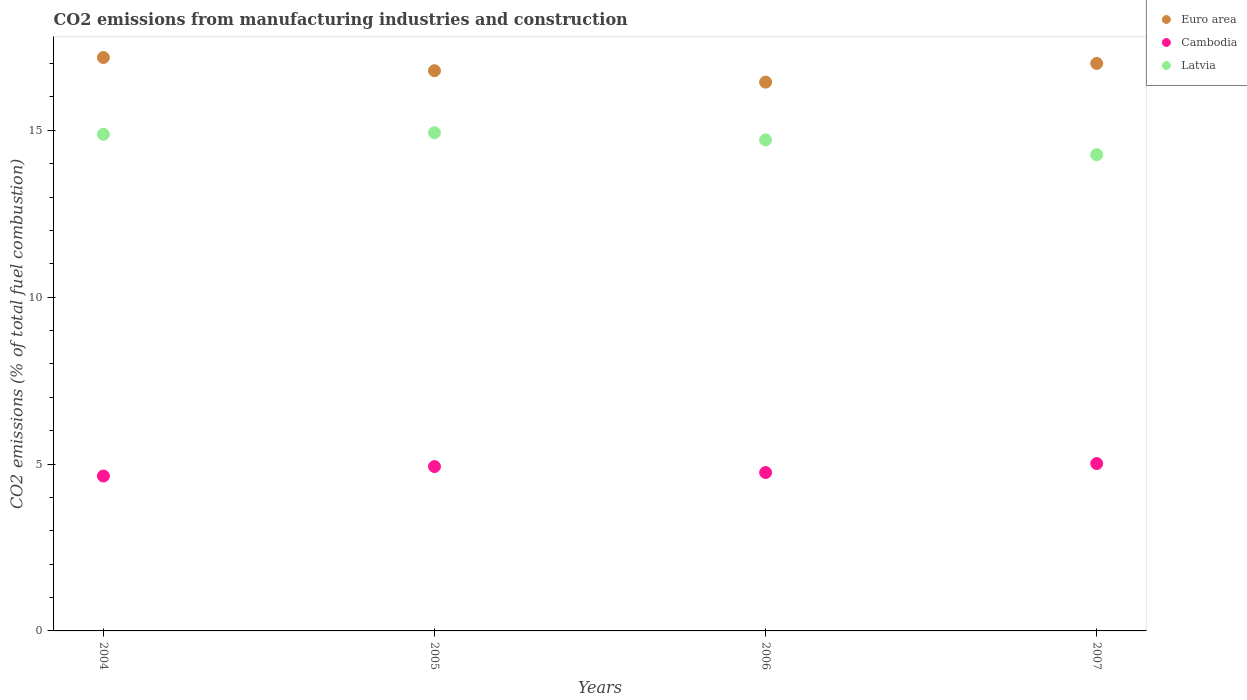Is the number of dotlines equal to the number of legend labels?
Provide a succinct answer. Yes. What is the amount of CO2 emitted in Euro area in 2007?
Your response must be concise. 17. Across all years, what is the maximum amount of CO2 emitted in Cambodia?
Offer a very short reply. 5.01. Across all years, what is the minimum amount of CO2 emitted in Cambodia?
Offer a terse response. 4.64. In which year was the amount of CO2 emitted in Cambodia minimum?
Offer a terse response. 2004. What is the total amount of CO2 emitted in Latvia in the graph?
Provide a succinct answer. 58.79. What is the difference between the amount of CO2 emitted in Latvia in 2005 and that in 2007?
Keep it short and to the point. 0.66. What is the difference between the amount of CO2 emitted in Latvia in 2004 and the amount of CO2 emitted in Euro area in 2007?
Give a very brief answer. -2.12. What is the average amount of CO2 emitted in Cambodia per year?
Ensure brevity in your answer.  4.83. In the year 2005, what is the difference between the amount of CO2 emitted in Cambodia and amount of CO2 emitted in Latvia?
Provide a succinct answer. -10. What is the ratio of the amount of CO2 emitted in Cambodia in 2004 to that in 2006?
Make the answer very short. 0.98. What is the difference between the highest and the second highest amount of CO2 emitted in Cambodia?
Offer a terse response. 0.09. What is the difference between the highest and the lowest amount of CO2 emitted in Cambodia?
Ensure brevity in your answer.  0.37. Is the sum of the amount of CO2 emitted in Cambodia in 2005 and 2007 greater than the maximum amount of CO2 emitted in Latvia across all years?
Keep it short and to the point. No. Does the amount of CO2 emitted in Cambodia monotonically increase over the years?
Offer a very short reply. No. Is the amount of CO2 emitted in Cambodia strictly less than the amount of CO2 emitted in Latvia over the years?
Your response must be concise. Yes. What is the difference between two consecutive major ticks on the Y-axis?
Give a very brief answer. 5. Does the graph contain any zero values?
Your answer should be very brief. No. Where does the legend appear in the graph?
Your answer should be compact. Top right. How are the legend labels stacked?
Offer a very short reply. Vertical. What is the title of the graph?
Your answer should be very brief. CO2 emissions from manufacturing industries and construction. Does "Marshall Islands" appear as one of the legend labels in the graph?
Offer a very short reply. No. What is the label or title of the X-axis?
Offer a very short reply. Years. What is the label or title of the Y-axis?
Offer a very short reply. CO2 emissions (% of total fuel combustion). What is the CO2 emissions (% of total fuel combustion) of Euro area in 2004?
Make the answer very short. 17.18. What is the CO2 emissions (% of total fuel combustion) in Cambodia in 2004?
Provide a short and direct response. 4.64. What is the CO2 emissions (% of total fuel combustion) in Latvia in 2004?
Provide a short and direct response. 14.88. What is the CO2 emissions (% of total fuel combustion) of Euro area in 2005?
Your answer should be compact. 16.78. What is the CO2 emissions (% of total fuel combustion) of Cambodia in 2005?
Your answer should be very brief. 4.92. What is the CO2 emissions (% of total fuel combustion) in Latvia in 2005?
Ensure brevity in your answer.  14.93. What is the CO2 emissions (% of total fuel combustion) in Euro area in 2006?
Offer a very short reply. 16.44. What is the CO2 emissions (% of total fuel combustion) of Cambodia in 2006?
Make the answer very short. 4.75. What is the CO2 emissions (% of total fuel combustion) in Latvia in 2006?
Your answer should be compact. 14.71. What is the CO2 emissions (% of total fuel combustion) of Euro area in 2007?
Your answer should be compact. 17. What is the CO2 emissions (% of total fuel combustion) of Cambodia in 2007?
Keep it short and to the point. 5.01. What is the CO2 emissions (% of total fuel combustion) in Latvia in 2007?
Make the answer very short. 14.27. Across all years, what is the maximum CO2 emissions (% of total fuel combustion) in Euro area?
Provide a short and direct response. 17.18. Across all years, what is the maximum CO2 emissions (% of total fuel combustion) in Cambodia?
Your answer should be compact. 5.01. Across all years, what is the maximum CO2 emissions (% of total fuel combustion) in Latvia?
Provide a succinct answer. 14.93. Across all years, what is the minimum CO2 emissions (% of total fuel combustion) of Euro area?
Your response must be concise. 16.44. Across all years, what is the minimum CO2 emissions (% of total fuel combustion) in Cambodia?
Give a very brief answer. 4.64. Across all years, what is the minimum CO2 emissions (% of total fuel combustion) of Latvia?
Your answer should be compact. 14.27. What is the total CO2 emissions (% of total fuel combustion) in Euro area in the graph?
Provide a short and direct response. 67.41. What is the total CO2 emissions (% of total fuel combustion) in Cambodia in the graph?
Your response must be concise. 19.33. What is the total CO2 emissions (% of total fuel combustion) in Latvia in the graph?
Give a very brief answer. 58.79. What is the difference between the CO2 emissions (% of total fuel combustion) of Euro area in 2004 and that in 2005?
Give a very brief answer. 0.4. What is the difference between the CO2 emissions (% of total fuel combustion) of Cambodia in 2004 and that in 2005?
Give a very brief answer. -0.28. What is the difference between the CO2 emissions (% of total fuel combustion) in Latvia in 2004 and that in 2005?
Your answer should be compact. -0.05. What is the difference between the CO2 emissions (% of total fuel combustion) in Euro area in 2004 and that in 2006?
Your answer should be compact. 0.74. What is the difference between the CO2 emissions (% of total fuel combustion) of Cambodia in 2004 and that in 2006?
Ensure brevity in your answer.  -0.1. What is the difference between the CO2 emissions (% of total fuel combustion) in Latvia in 2004 and that in 2006?
Your response must be concise. 0.17. What is the difference between the CO2 emissions (% of total fuel combustion) of Euro area in 2004 and that in 2007?
Your answer should be compact. 0.18. What is the difference between the CO2 emissions (% of total fuel combustion) of Cambodia in 2004 and that in 2007?
Provide a succinct answer. -0.37. What is the difference between the CO2 emissions (% of total fuel combustion) in Latvia in 2004 and that in 2007?
Your answer should be compact. 0.61. What is the difference between the CO2 emissions (% of total fuel combustion) of Euro area in 2005 and that in 2006?
Provide a succinct answer. 0.34. What is the difference between the CO2 emissions (% of total fuel combustion) of Cambodia in 2005 and that in 2006?
Your answer should be compact. 0.18. What is the difference between the CO2 emissions (% of total fuel combustion) in Latvia in 2005 and that in 2006?
Provide a succinct answer. 0.21. What is the difference between the CO2 emissions (% of total fuel combustion) in Euro area in 2005 and that in 2007?
Give a very brief answer. -0.22. What is the difference between the CO2 emissions (% of total fuel combustion) in Cambodia in 2005 and that in 2007?
Provide a succinct answer. -0.09. What is the difference between the CO2 emissions (% of total fuel combustion) in Latvia in 2005 and that in 2007?
Give a very brief answer. 0.66. What is the difference between the CO2 emissions (% of total fuel combustion) of Euro area in 2006 and that in 2007?
Your answer should be very brief. -0.56. What is the difference between the CO2 emissions (% of total fuel combustion) in Cambodia in 2006 and that in 2007?
Offer a very short reply. -0.27. What is the difference between the CO2 emissions (% of total fuel combustion) in Latvia in 2006 and that in 2007?
Make the answer very short. 0.44. What is the difference between the CO2 emissions (% of total fuel combustion) of Euro area in 2004 and the CO2 emissions (% of total fuel combustion) of Cambodia in 2005?
Ensure brevity in your answer.  12.26. What is the difference between the CO2 emissions (% of total fuel combustion) in Euro area in 2004 and the CO2 emissions (% of total fuel combustion) in Latvia in 2005?
Provide a succinct answer. 2.25. What is the difference between the CO2 emissions (% of total fuel combustion) of Cambodia in 2004 and the CO2 emissions (% of total fuel combustion) of Latvia in 2005?
Keep it short and to the point. -10.29. What is the difference between the CO2 emissions (% of total fuel combustion) of Euro area in 2004 and the CO2 emissions (% of total fuel combustion) of Cambodia in 2006?
Give a very brief answer. 12.43. What is the difference between the CO2 emissions (% of total fuel combustion) in Euro area in 2004 and the CO2 emissions (% of total fuel combustion) in Latvia in 2006?
Your answer should be very brief. 2.47. What is the difference between the CO2 emissions (% of total fuel combustion) in Cambodia in 2004 and the CO2 emissions (% of total fuel combustion) in Latvia in 2006?
Provide a short and direct response. -10.07. What is the difference between the CO2 emissions (% of total fuel combustion) in Euro area in 2004 and the CO2 emissions (% of total fuel combustion) in Cambodia in 2007?
Provide a succinct answer. 12.17. What is the difference between the CO2 emissions (% of total fuel combustion) in Euro area in 2004 and the CO2 emissions (% of total fuel combustion) in Latvia in 2007?
Provide a succinct answer. 2.91. What is the difference between the CO2 emissions (% of total fuel combustion) of Cambodia in 2004 and the CO2 emissions (% of total fuel combustion) of Latvia in 2007?
Your response must be concise. -9.63. What is the difference between the CO2 emissions (% of total fuel combustion) in Euro area in 2005 and the CO2 emissions (% of total fuel combustion) in Cambodia in 2006?
Give a very brief answer. 12.04. What is the difference between the CO2 emissions (% of total fuel combustion) of Euro area in 2005 and the CO2 emissions (% of total fuel combustion) of Latvia in 2006?
Provide a succinct answer. 2.07. What is the difference between the CO2 emissions (% of total fuel combustion) of Cambodia in 2005 and the CO2 emissions (% of total fuel combustion) of Latvia in 2006?
Provide a short and direct response. -9.79. What is the difference between the CO2 emissions (% of total fuel combustion) of Euro area in 2005 and the CO2 emissions (% of total fuel combustion) of Cambodia in 2007?
Keep it short and to the point. 11.77. What is the difference between the CO2 emissions (% of total fuel combustion) of Euro area in 2005 and the CO2 emissions (% of total fuel combustion) of Latvia in 2007?
Provide a succinct answer. 2.52. What is the difference between the CO2 emissions (% of total fuel combustion) in Cambodia in 2005 and the CO2 emissions (% of total fuel combustion) in Latvia in 2007?
Your response must be concise. -9.34. What is the difference between the CO2 emissions (% of total fuel combustion) in Euro area in 2006 and the CO2 emissions (% of total fuel combustion) in Cambodia in 2007?
Offer a terse response. 11.43. What is the difference between the CO2 emissions (% of total fuel combustion) of Euro area in 2006 and the CO2 emissions (% of total fuel combustion) of Latvia in 2007?
Your answer should be compact. 2.17. What is the difference between the CO2 emissions (% of total fuel combustion) of Cambodia in 2006 and the CO2 emissions (% of total fuel combustion) of Latvia in 2007?
Your answer should be very brief. -9.52. What is the average CO2 emissions (% of total fuel combustion) of Euro area per year?
Give a very brief answer. 16.85. What is the average CO2 emissions (% of total fuel combustion) in Cambodia per year?
Give a very brief answer. 4.83. What is the average CO2 emissions (% of total fuel combustion) of Latvia per year?
Give a very brief answer. 14.7. In the year 2004, what is the difference between the CO2 emissions (% of total fuel combustion) in Euro area and CO2 emissions (% of total fuel combustion) in Cambodia?
Keep it short and to the point. 12.54. In the year 2004, what is the difference between the CO2 emissions (% of total fuel combustion) of Euro area and CO2 emissions (% of total fuel combustion) of Latvia?
Provide a succinct answer. 2.3. In the year 2004, what is the difference between the CO2 emissions (% of total fuel combustion) in Cambodia and CO2 emissions (% of total fuel combustion) in Latvia?
Offer a terse response. -10.24. In the year 2005, what is the difference between the CO2 emissions (% of total fuel combustion) in Euro area and CO2 emissions (% of total fuel combustion) in Cambodia?
Offer a terse response. 11.86. In the year 2005, what is the difference between the CO2 emissions (% of total fuel combustion) of Euro area and CO2 emissions (% of total fuel combustion) of Latvia?
Make the answer very short. 1.86. In the year 2005, what is the difference between the CO2 emissions (% of total fuel combustion) in Cambodia and CO2 emissions (% of total fuel combustion) in Latvia?
Ensure brevity in your answer.  -10. In the year 2006, what is the difference between the CO2 emissions (% of total fuel combustion) in Euro area and CO2 emissions (% of total fuel combustion) in Cambodia?
Make the answer very short. 11.7. In the year 2006, what is the difference between the CO2 emissions (% of total fuel combustion) in Euro area and CO2 emissions (% of total fuel combustion) in Latvia?
Offer a very short reply. 1.73. In the year 2006, what is the difference between the CO2 emissions (% of total fuel combustion) in Cambodia and CO2 emissions (% of total fuel combustion) in Latvia?
Make the answer very short. -9.97. In the year 2007, what is the difference between the CO2 emissions (% of total fuel combustion) in Euro area and CO2 emissions (% of total fuel combustion) in Cambodia?
Keep it short and to the point. 11.99. In the year 2007, what is the difference between the CO2 emissions (% of total fuel combustion) in Euro area and CO2 emissions (% of total fuel combustion) in Latvia?
Your answer should be very brief. 2.73. In the year 2007, what is the difference between the CO2 emissions (% of total fuel combustion) in Cambodia and CO2 emissions (% of total fuel combustion) in Latvia?
Your answer should be compact. -9.25. What is the ratio of the CO2 emissions (% of total fuel combustion) of Euro area in 2004 to that in 2005?
Your response must be concise. 1.02. What is the ratio of the CO2 emissions (% of total fuel combustion) of Cambodia in 2004 to that in 2005?
Make the answer very short. 0.94. What is the ratio of the CO2 emissions (% of total fuel combustion) in Latvia in 2004 to that in 2005?
Provide a succinct answer. 1. What is the ratio of the CO2 emissions (% of total fuel combustion) of Euro area in 2004 to that in 2006?
Your response must be concise. 1.04. What is the ratio of the CO2 emissions (% of total fuel combustion) of Cambodia in 2004 to that in 2006?
Provide a succinct answer. 0.98. What is the ratio of the CO2 emissions (% of total fuel combustion) in Latvia in 2004 to that in 2006?
Keep it short and to the point. 1.01. What is the ratio of the CO2 emissions (% of total fuel combustion) of Euro area in 2004 to that in 2007?
Provide a succinct answer. 1.01. What is the ratio of the CO2 emissions (% of total fuel combustion) in Cambodia in 2004 to that in 2007?
Offer a terse response. 0.93. What is the ratio of the CO2 emissions (% of total fuel combustion) of Latvia in 2004 to that in 2007?
Provide a short and direct response. 1.04. What is the ratio of the CO2 emissions (% of total fuel combustion) of Euro area in 2005 to that in 2006?
Provide a succinct answer. 1.02. What is the ratio of the CO2 emissions (% of total fuel combustion) of Cambodia in 2005 to that in 2006?
Keep it short and to the point. 1.04. What is the ratio of the CO2 emissions (% of total fuel combustion) in Latvia in 2005 to that in 2006?
Your answer should be very brief. 1.01. What is the ratio of the CO2 emissions (% of total fuel combustion) of Euro area in 2005 to that in 2007?
Give a very brief answer. 0.99. What is the ratio of the CO2 emissions (% of total fuel combustion) in Cambodia in 2005 to that in 2007?
Keep it short and to the point. 0.98. What is the ratio of the CO2 emissions (% of total fuel combustion) in Latvia in 2005 to that in 2007?
Your response must be concise. 1.05. What is the ratio of the CO2 emissions (% of total fuel combustion) in Euro area in 2006 to that in 2007?
Provide a succinct answer. 0.97. What is the ratio of the CO2 emissions (% of total fuel combustion) in Cambodia in 2006 to that in 2007?
Offer a very short reply. 0.95. What is the ratio of the CO2 emissions (% of total fuel combustion) of Latvia in 2006 to that in 2007?
Give a very brief answer. 1.03. What is the difference between the highest and the second highest CO2 emissions (% of total fuel combustion) in Euro area?
Offer a very short reply. 0.18. What is the difference between the highest and the second highest CO2 emissions (% of total fuel combustion) in Cambodia?
Ensure brevity in your answer.  0.09. What is the difference between the highest and the second highest CO2 emissions (% of total fuel combustion) in Latvia?
Make the answer very short. 0.05. What is the difference between the highest and the lowest CO2 emissions (% of total fuel combustion) in Euro area?
Make the answer very short. 0.74. What is the difference between the highest and the lowest CO2 emissions (% of total fuel combustion) of Cambodia?
Ensure brevity in your answer.  0.37. What is the difference between the highest and the lowest CO2 emissions (% of total fuel combustion) in Latvia?
Give a very brief answer. 0.66. 